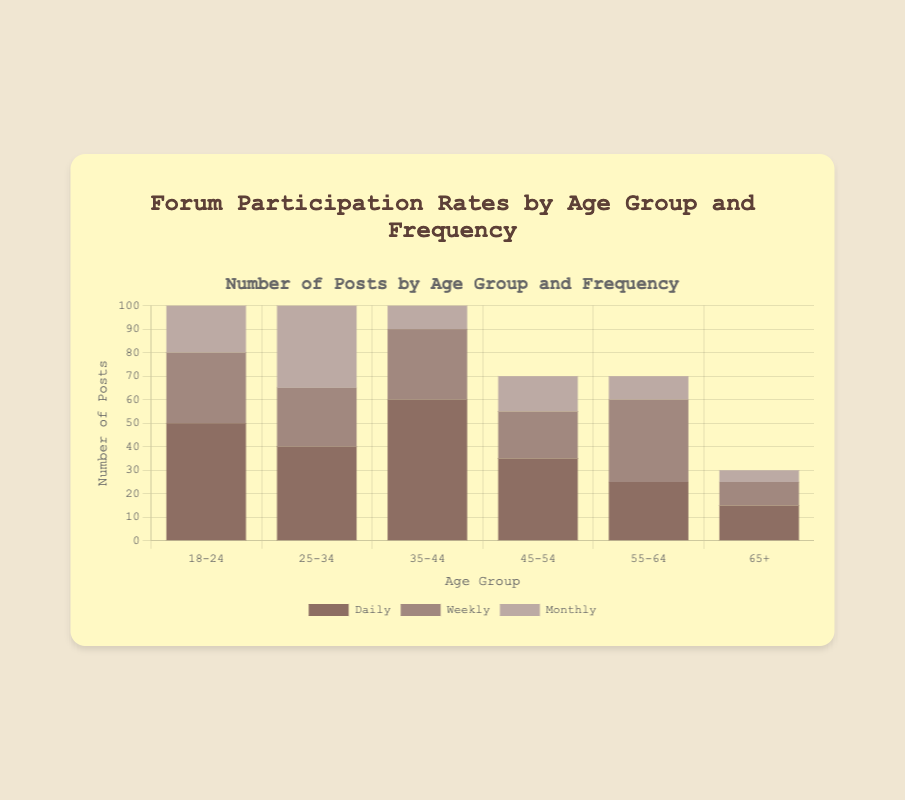What's the total number of posts from the 35-44 age group? To find the total number of posts for the 35-44 age group, sum the daily, weekly, and monthly posts: 60 (daily) + 30 (weekly) + 10 (monthly) = 100
Answer: 100 Which age group has the highest number of daily posts? By visually comparing the height of the daily bars across age groups, the 35-44 age group has the highest bar, indicating the most daily posts.
Answer: 35-44 How many more posts are made by the 18-24 age group compared to the 65+ age group? Calculate the total posts for each age group and find the difference. 18-24: 50 (daily) + 30 (weekly) + 20 (monthly) = 100; 65+: 15 (daily) + 10 (weekly) + 5 (monthly) = 30. Difference: 100 - 30 = 70
Answer: 70 What is the average number of monthly posts across all age groups? Sum all the monthly posts and divide by the number of age groups. Monthly posts: 20 + 35 + 10 + 15 + 10 + 5 = 95. There are 6 age groups, so the average is 95 / 6 ≈ 15.83
Answer: 15.83 Which participation type has the smallest number of posts in the 45-54 age group? Visually inspect the height of the daily, weekly, and monthly bars for the 45-54 age group. The monthly bar is the shortest, indicating it has the fewest posts.
Answer: Monthly Are there more weekly posts from the 55-64 age group or monthly posts from the 25-34 age group? Compare the weekly posts bar for 55-64 (35 posts) with the monthly posts bar for 25-34 (35 posts). Both have equal posts.
Answer: Equal What is the total number of weekly posts across all age groups? Sum all the weekly posts: 30 (18-24) + 25 (25-34) + 30 (35-44) + 20 (45-54) + 35 (55-64) + 10 (65+) = 150
Answer: 150 Which age group has the highest total number of posts? Sum the posts for each age group and identify the highest. 35-44: 100; 18-24, 25-34: 100; 45-54: 70; 55-64: 70; 65+: 30. The 35-44 age group has the highest total.
Answer: 35-44 Is the total number of posts from the 25-34 age group greater than the 45-54 and 65+ age groups combined? Calculate the total posts for each group and compare. 25-34: 40 (daily) + 25 (weekly) + 35 (monthly) = 100; 45-54: 35 + 20 + 15 = 70; 65+: 15 + 10 + 5 = 30. Combined: 70 + 30 = 100; Comparison: 100 = 100, so they are equal.
Answer: Equal Does the 18-24 age group have more daily posts than the 55-64 age group has weekly posts? Compare the daily posts bar for 18-24 (50) with the weekly posts bar for 55-64 (35). The 18-24 age group has more daily posts.
Answer: Yes 